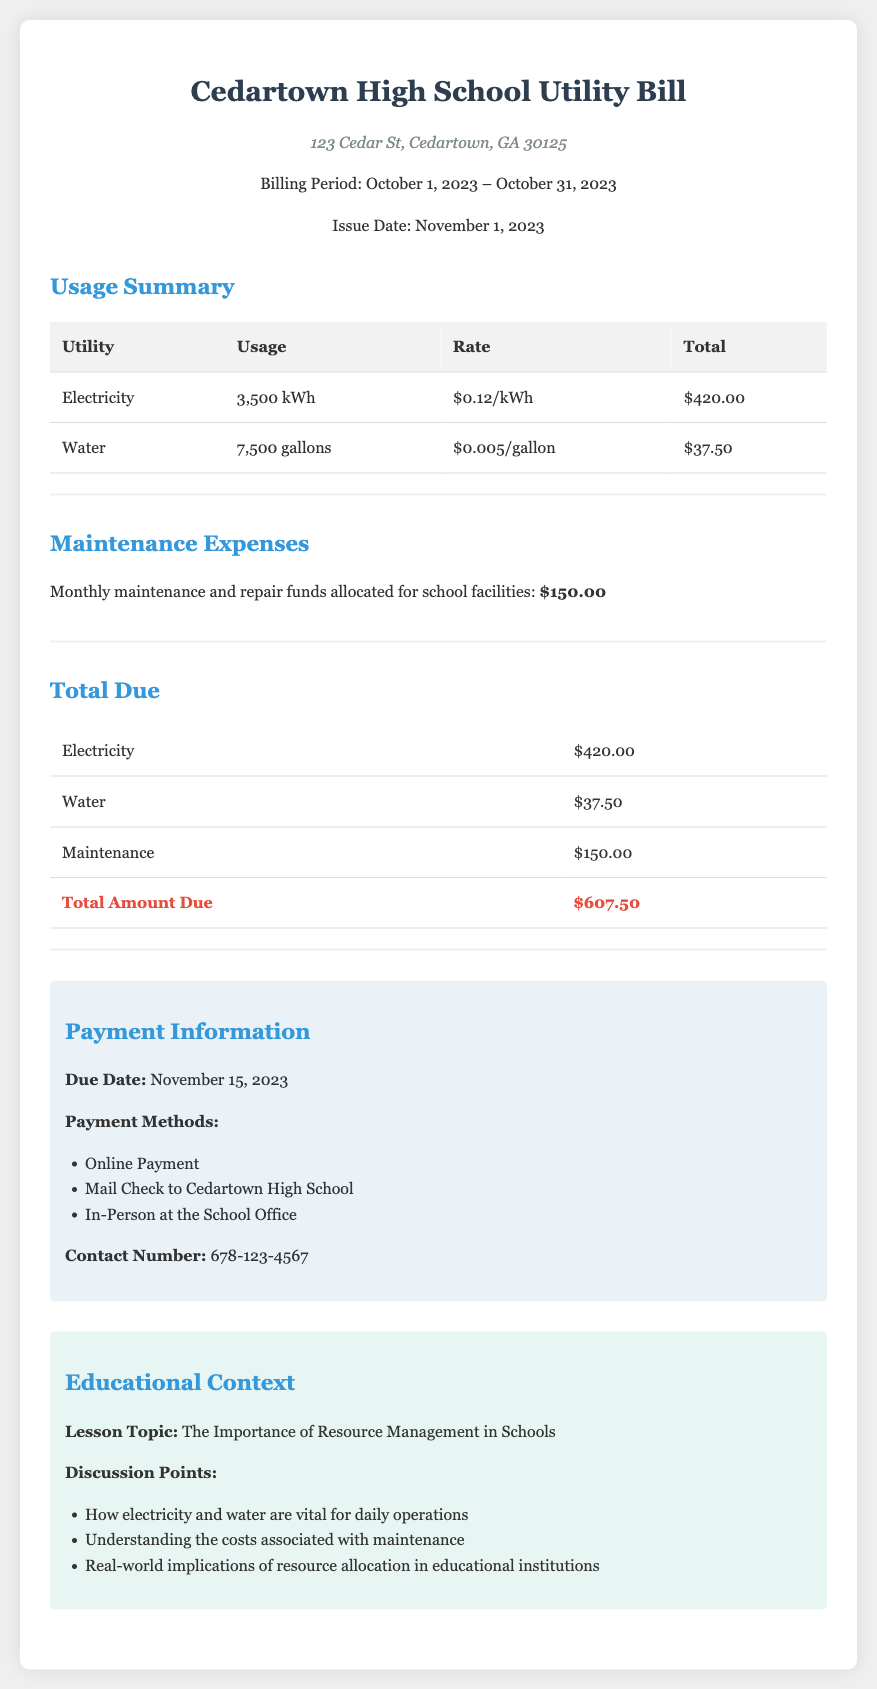What is the total electricity usage? The total electricity usage is specified in the "Usage Summary" section of the document as 3,500 kWh.
Answer: 3,500 kWh What is the rate per gallon of water? The rate per gallon of water is provided in the "Usage Summary" section of the document as $0.005/gallon.
Answer: $0.005/gallon What is the total amount due? The total amount due is listed at the bottom of the "Total Due" section of the document as $607.50.
Answer: $607.50 What is the allocation for maintenance expenses? The maintenance expenses allocated for school facilities are stated clearly in the "Maintenance Expenses" section as $150.00.
Answer: $150.00 What is the due date for the payment? The due date for payment is mentioned in the "Payment Information" section as November 15, 2023.
Answer: November 15, 2023 How many gallons of water were used? The total water usage is indicated in the "Usage Summary" section as 7,500 gallons.
Answer: 7,500 gallons What is the total cost of electricity? The total cost of electricity is detailed in the "Total Due" section as $420.00.
Answer: $420.00 What are the listed payment methods? The payment methods are discussed in the "Payment Information" section, which includes online payment, mail check, and in-person payment.
Answer: Online Payment, Mail Check to Cedartown High School, In-Person at the School Office What lesson topic is suggested in the educational context? The suggested lesson topic in the "Educational Context" section is The Importance of Resource Management in Schools.
Answer: The Importance of Resource Management in Schools 